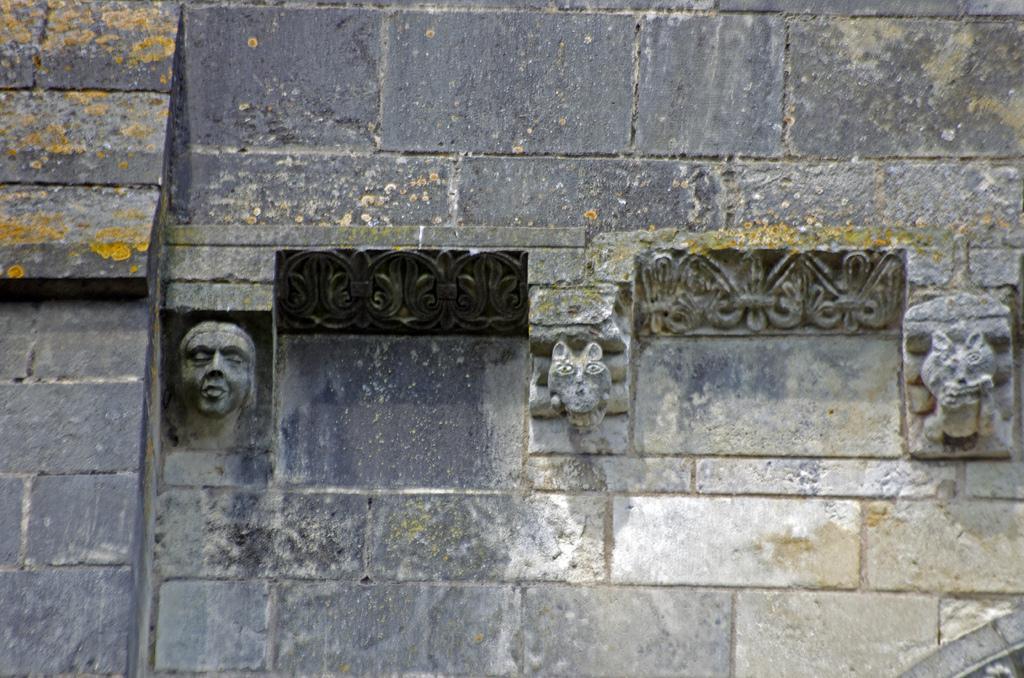In one or two sentences, can you explain what this image depicts? This image consists of a wall on which we can see the structures of human face and the animals. 